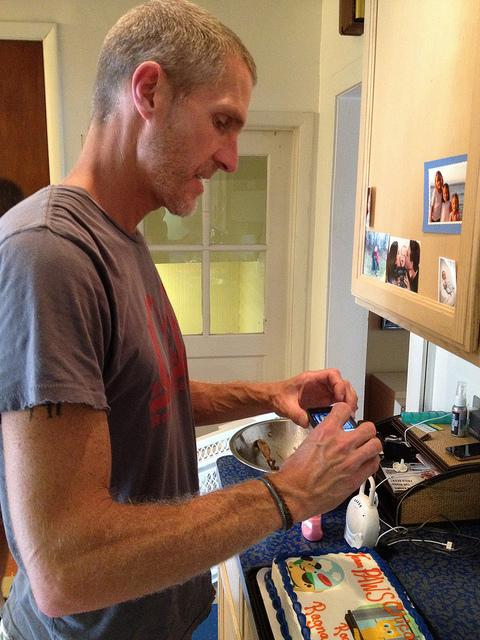What is the blue rectangular plastic item used to hold at the top of the desk? Please explain your reasoning. pills. The item is for pills. 